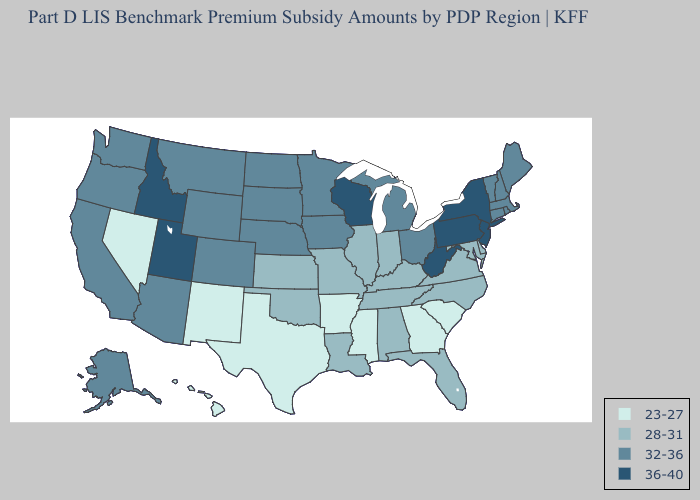What is the lowest value in states that border Illinois?
Short answer required. 28-31. Does Tennessee have the highest value in the USA?
Answer briefly. No. Name the states that have a value in the range 32-36?
Keep it brief. Alaska, Arizona, California, Colorado, Connecticut, Iowa, Maine, Massachusetts, Michigan, Minnesota, Montana, Nebraska, New Hampshire, North Dakota, Ohio, Oregon, Rhode Island, South Dakota, Vermont, Washington, Wyoming. Does Hawaii have the lowest value in the USA?
Concise answer only. Yes. Name the states that have a value in the range 32-36?
Keep it brief. Alaska, Arizona, California, Colorado, Connecticut, Iowa, Maine, Massachusetts, Michigan, Minnesota, Montana, Nebraska, New Hampshire, North Dakota, Ohio, Oregon, Rhode Island, South Dakota, Vermont, Washington, Wyoming. Name the states that have a value in the range 32-36?
Quick response, please. Alaska, Arizona, California, Colorado, Connecticut, Iowa, Maine, Massachusetts, Michigan, Minnesota, Montana, Nebraska, New Hampshire, North Dakota, Ohio, Oregon, Rhode Island, South Dakota, Vermont, Washington, Wyoming. What is the lowest value in the South?
Keep it brief. 23-27. What is the value of New Hampshire?
Give a very brief answer. 32-36. What is the value of Delaware?
Give a very brief answer. 28-31. Name the states that have a value in the range 23-27?
Be succinct. Arkansas, Georgia, Hawaii, Mississippi, Nevada, New Mexico, South Carolina, Texas. What is the highest value in the USA?
Short answer required. 36-40. What is the value of South Dakota?
Quick response, please. 32-36. What is the lowest value in the MidWest?
Quick response, please. 28-31. What is the value of Montana?
Be succinct. 32-36. What is the value of Massachusetts?
Be succinct. 32-36. 